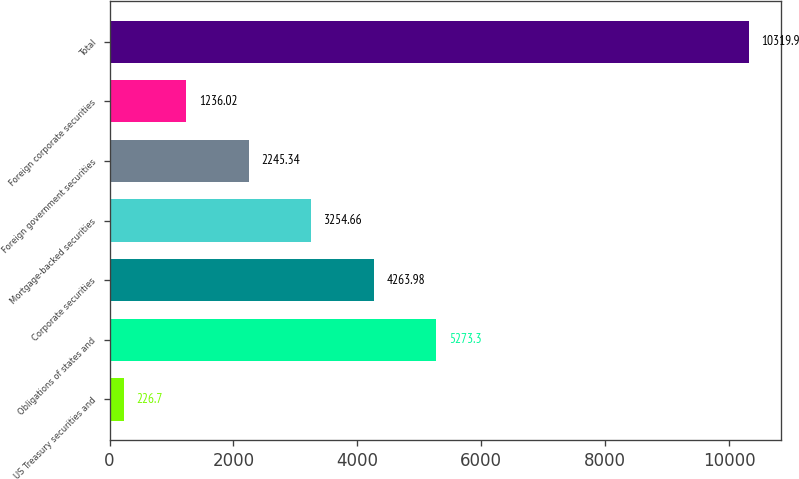Convert chart. <chart><loc_0><loc_0><loc_500><loc_500><bar_chart><fcel>US Treasury securities and<fcel>Obligations of states and<fcel>Corporate securities<fcel>Mortgage-backed securities<fcel>Foreign government securities<fcel>Foreign corporate securities<fcel>Total<nl><fcel>226.7<fcel>5273.3<fcel>4263.98<fcel>3254.66<fcel>2245.34<fcel>1236.02<fcel>10319.9<nl></chart> 